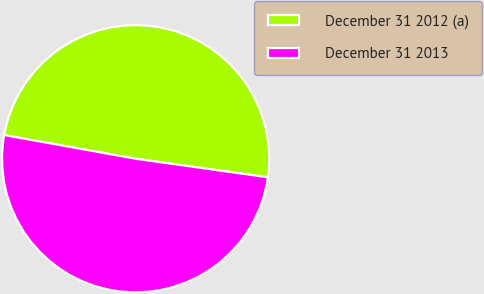Convert chart to OTSL. <chart><loc_0><loc_0><loc_500><loc_500><pie_chart><fcel>December 31 2012 (a)<fcel>December 31 2013<nl><fcel>49.38%<fcel>50.62%<nl></chart> 